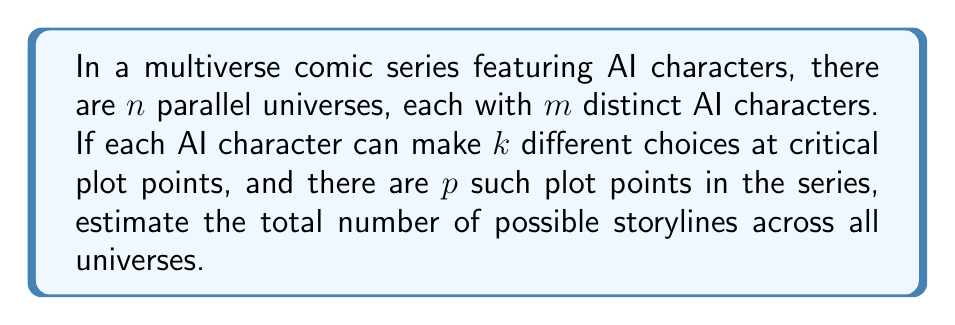Can you answer this question? Let's approach this step-by-step:

1) In each universe, we have $m$ AI characters.

2) Each character faces $p$ critical plot points.

3) At each plot point, a character has $k$ choices.

4) For a single character in one universe, the number of possible storylines is:

   $$k^p$$

5) For all $m$ characters in one universe, the number of possible combinations is:

   $$(k^p)^m = k^{pm}$$

6) This calculation is repeated for each of the $n$ parallel universes.

7) Therefore, the total number of possible storylines across all universes is:

   $$n \cdot k^{pm}$$

8) Given that we're dealing with multiple universes and AI characters, this number is likely to be extremely large. It's more appropriate to express it in scientific notation or as an order of magnitude.

9) Let's say $n = 10$, $m = 5$, $k = 3$, and $p = 10$:

   $$10 \cdot 3^{5 \cdot 10} = 10 \cdot 3^{50} \approx 7.18 \times 10^{24}$$

This demonstrates the vast number of possibilities in a multiverse comic series with AI characters.
Answer: $n \cdot k^{pm}$ 